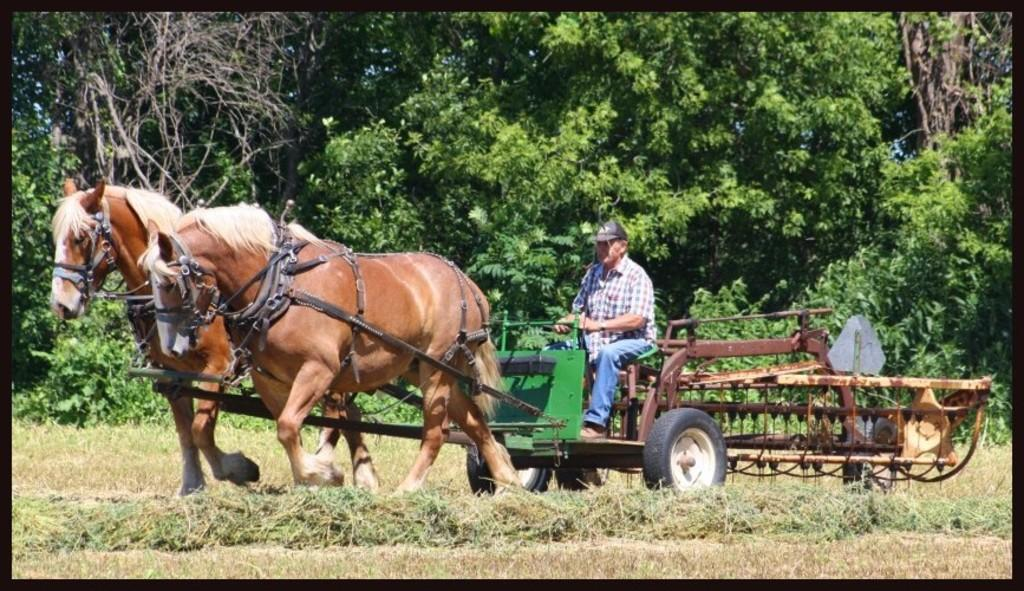What type of vegetation is present in the image? There is grass in the image. What animals can be seen in the image? There are horses in the image. What type of equipment is visible in the image? There is a farm machine in the image. Can you describe the person in the image? There is a person in the image. What can be seen in the background of the image? There are trees in the background of the image. What part of the natural environment is visible in the image? The sky is visible in the image. What type of pail is the father holding while walking with his daughter in the image? There is no father or daughter present in the image, nor is there a pail visible. 